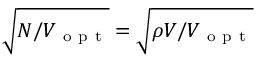Convert formula to latex. <formula><loc_0><loc_0><loc_500><loc_500>\sqrt { N / V _ { o p t } } = \sqrt { \rho V / V _ { o p t } }</formula> 